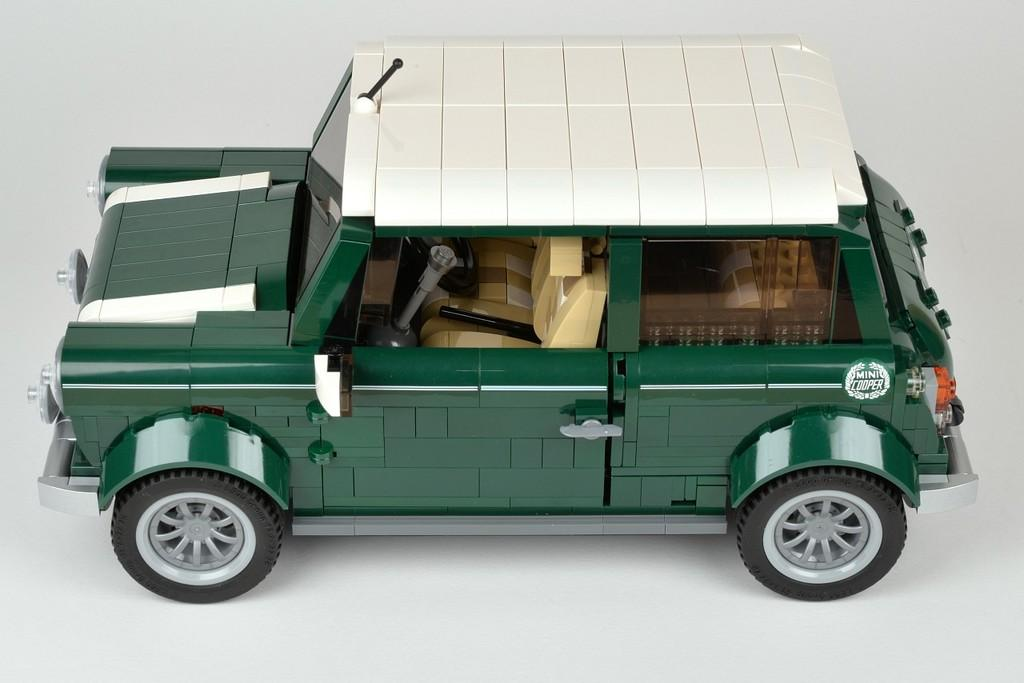What is the main subject of the image? The main subject of the image is a toy car. Where is the toy car located in the image? The toy car is in the center of the image. What type of feast is being prepared in the image? There is no feast present in the image; it only features a toy car. How old is the baby in the image? There is no baby present in the image; it only features a toy car. 